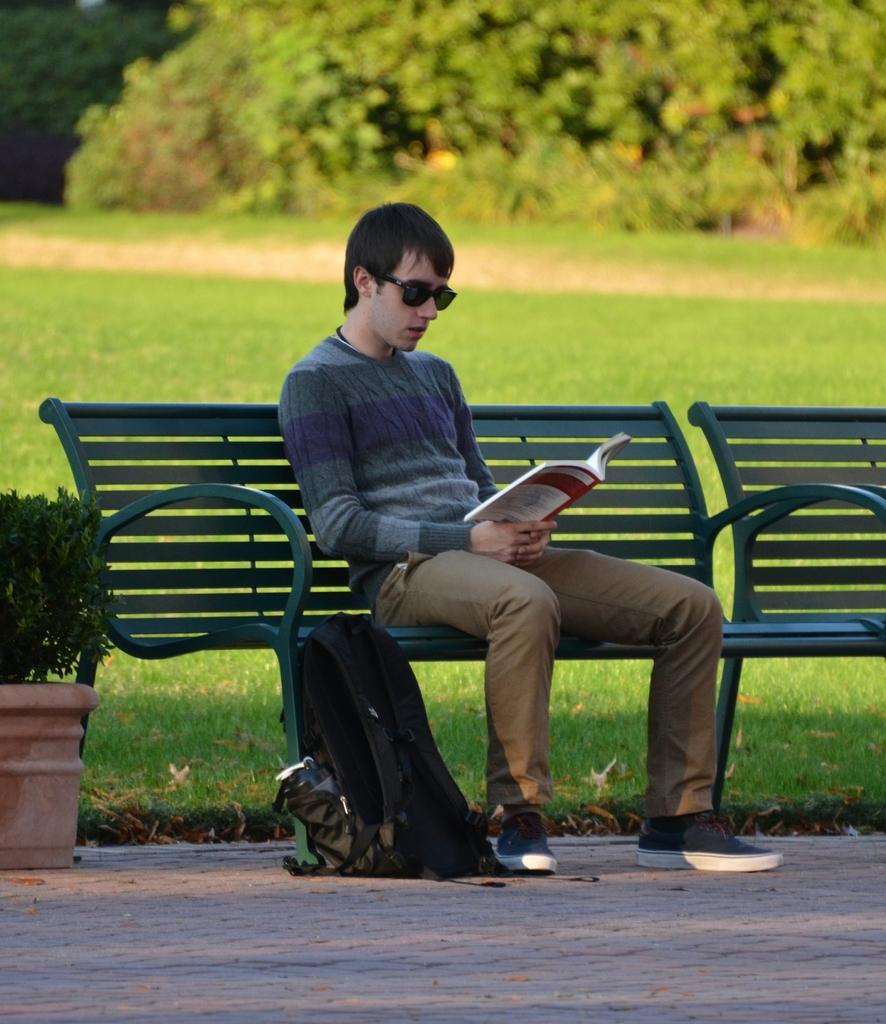Describe this image in one or two sentences. a person is sitting on a green bench reading a book. he is wearing goggles. to his left there is a black bag. at the left there is a plant. at the back there is grass and trees. 